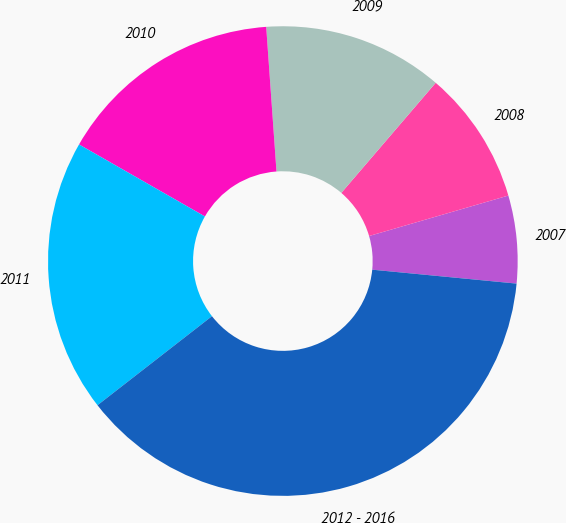Convert chart to OTSL. <chart><loc_0><loc_0><loc_500><loc_500><pie_chart><fcel>2007<fcel>2008<fcel>2009<fcel>2010<fcel>2011<fcel>2012 - 2016<nl><fcel>6.03%<fcel>9.22%<fcel>12.41%<fcel>15.6%<fcel>18.79%<fcel>37.95%<nl></chart> 